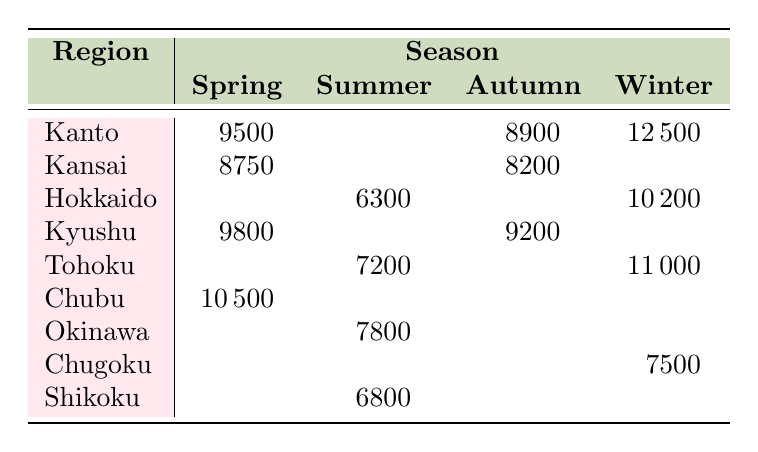What's the total sales of Camellia Oil in Winter? The sales for Camellia Oil in the Winter season is listed as 12500. Since there is only one data point for this product and season, this is the total sales.
Answer: 12500 Which product had the highest sales in Kansai? From the table, the only product listed for Kansai in Spring is Rice Bran Face Mask with sales of 8750 and in Autumn, Rice Water Cleanser with 8200. Therefore, the highest sales product in Kansai is Rice Bran Face Mask with 8750.
Answer: Rice Bran Face Mask Is there any product sold in Summer in Tohoku? Looking at the table for Tohoku, the only season listed with sales is in Winter (for Sake Essence Lotion) and in Summer, there are no sales shown. Thus, there is no product sold in Tohoku in Summer.
Answer: No What is the average sales for products sold in Spring? The products sold in Spring are Cherry Blossom Hand Cream (9500), Rice Bran Face Mask (8750), and Matcha Face Cream (10500). Summing these gives 9500 + 8750 + 10500 = 28750. There are three products, so the average is 28750 / 3 = 9583.33.
Answer: 9583.33 Which region has the highest sales in Winter and what is the value? The regions with sales in Winter are Kanto (12500), Tohoku (11000), Yuzu Body Scrub in Hokkaido (10200), and Soy Milk Moisturizer in Chugoku (7500). The highest among these is Kanto with 12500.
Answer: Kanto, 12500 Does Okinawa have any products listed for Autumn? In the table, Okinawa has no products listed under Autumn season, as there are no sales numbers provided for that season. Thus, we can conclude that there are no products sold in Autumn in Okinawa.
Answer: No Which region sold the most units in Summer and what were the units sold? The products sold in Summer include Green Tea Toner in Hokkaido (900), Seaweed Face Mask in Okinawa (1300), and Camellia Oil in Shikoku (1360). The highest value is Camellia Oil in Shikoku with 1360 units sold.
Answer: Shikoku, 1360 What is the difference in sales between the highest and lowest selling products in Autumn? The products sold in Autumn are Rice Water Cleanser in Kansai (8200), Yuzu Body Scrub in Kyushu (9200), and Green Tea Toner in Kanto (8900). The highest is Yuzu Body Scrub (9200) and the lowest is Rice Water Cleanser (8200). The difference is 9200 - 8200 = 1000.
Answer: 1000 How many products showed sales in the Summer season? From the table, there are three products listed under Summer: Green Tea Toner in Hokkaido, Seaweed Face Mask in Okinawa, and Camellia Oil in Shikoku, so there are three products that showed sales.
Answer: 3 